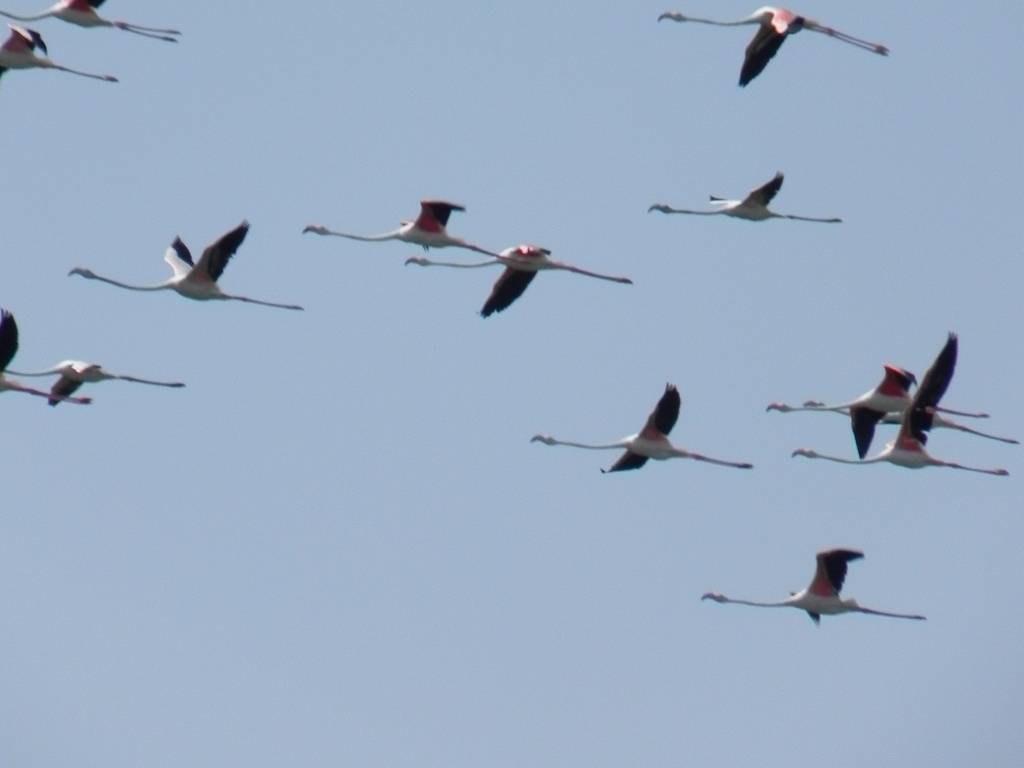What species of birds are these, and can you tell me about their habitat? These are flamingos, specifically the Greater Flamingo. They are known for their long necks, stick-like legs, and pink to red feather coloring. Flamingos are often found in warm, watery regions on many continents, including shallow lakes, lagoons, and swamps where they feed on shrimp, algae, and other small organisms that contribute to their vibrant feather color. 